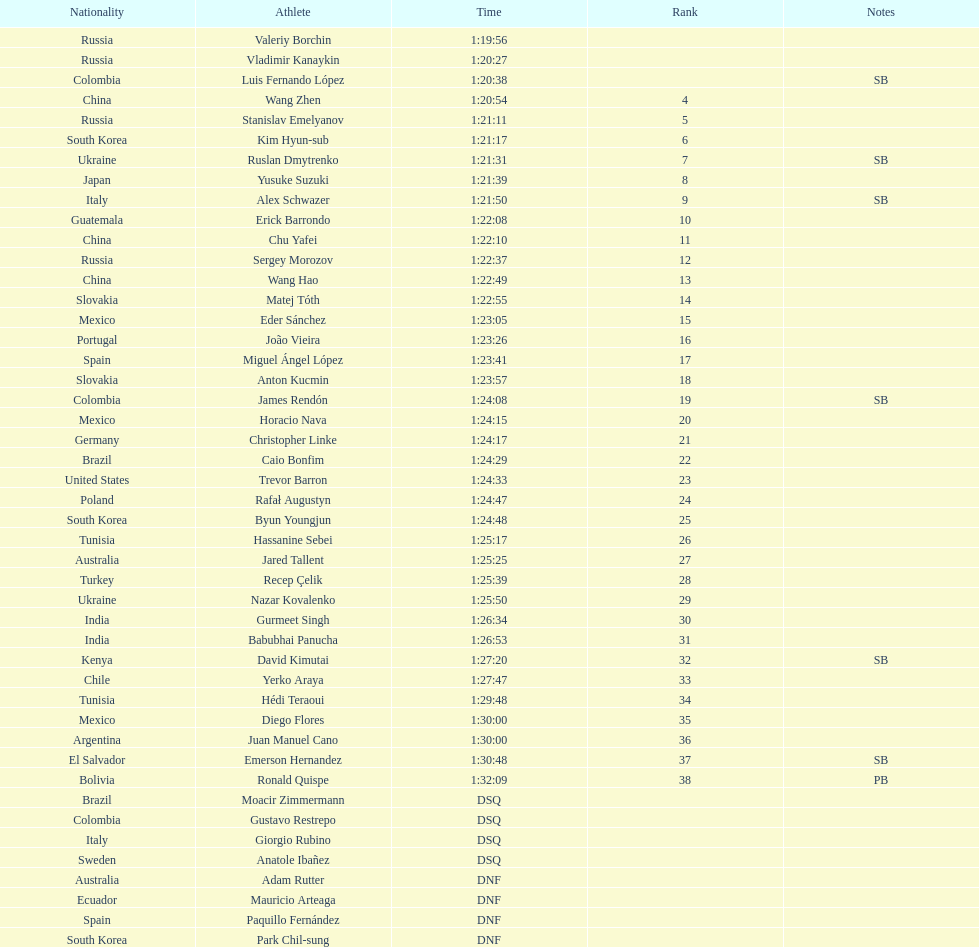Which competitor was ranked first? Valeriy Borchin. 